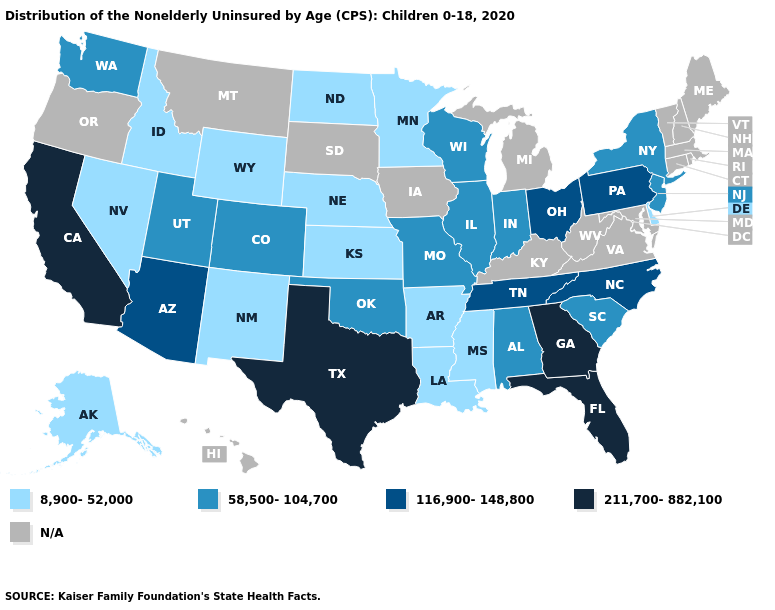What is the value of South Carolina?
Answer briefly. 58,500-104,700. Does the first symbol in the legend represent the smallest category?
Be succinct. Yes. What is the value of Wyoming?
Quick response, please. 8,900-52,000. How many symbols are there in the legend?
Concise answer only. 5. Name the states that have a value in the range N/A?
Answer briefly. Connecticut, Hawaii, Iowa, Kentucky, Maine, Maryland, Massachusetts, Michigan, Montana, New Hampshire, Oregon, Rhode Island, South Dakota, Vermont, Virginia, West Virginia. What is the lowest value in the West?
Be succinct. 8,900-52,000. What is the lowest value in the South?
Keep it brief. 8,900-52,000. Does New York have the lowest value in the USA?
Short answer required. No. What is the value of Montana?
Keep it brief. N/A. Does the first symbol in the legend represent the smallest category?
Quick response, please. Yes. What is the value of Kansas?
Quick response, please. 8,900-52,000. Which states hav the highest value in the South?
Give a very brief answer. Florida, Georgia, Texas. Which states have the lowest value in the South?
Answer briefly. Arkansas, Delaware, Louisiana, Mississippi. Name the states that have a value in the range N/A?
Short answer required. Connecticut, Hawaii, Iowa, Kentucky, Maine, Maryland, Massachusetts, Michigan, Montana, New Hampshire, Oregon, Rhode Island, South Dakota, Vermont, Virginia, West Virginia. 